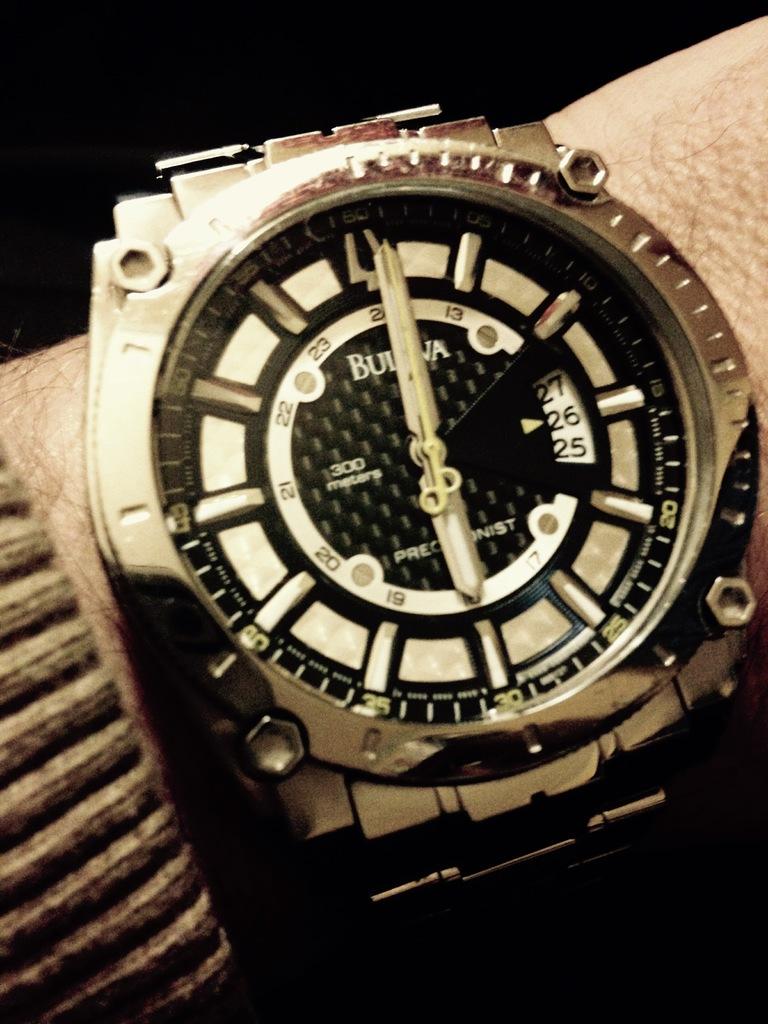What time is it on the watch?
Keep it short and to the point. 6:01. 